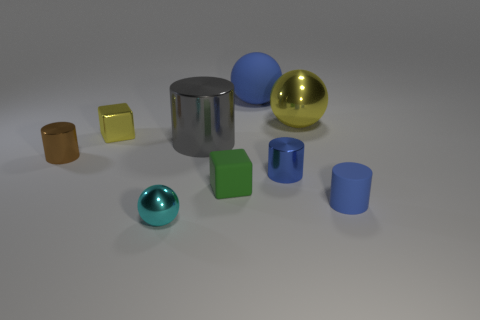Subtract 1 cylinders. How many cylinders are left? 3 Add 1 small things. How many objects exist? 10 Subtract all cylinders. How many objects are left? 5 Subtract 0 red spheres. How many objects are left? 9 Subtract all large shiny spheres. Subtract all large blue objects. How many objects are left? 7 Add 6 large blue objects. How many large blue objects are left? 7 Add 9 small green matte cubes. How many small green matte cubes exist? 10 